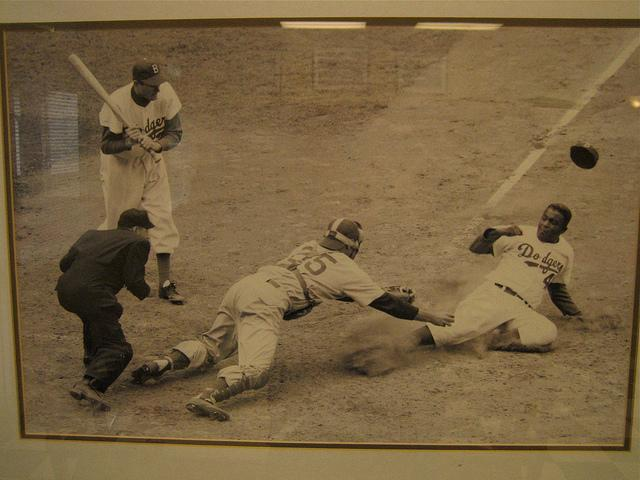What person is sliding? Please explain your reasoning. jackie robinson. This is jackie robinson. 